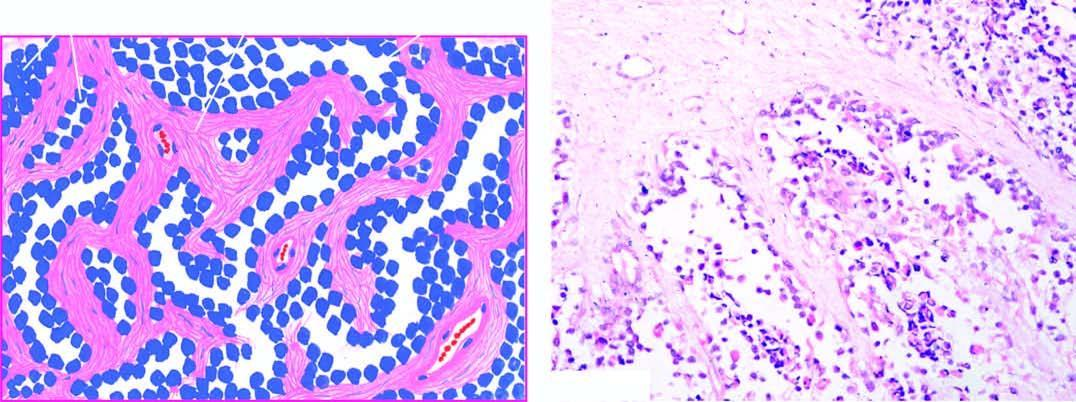re the interface between viable and non-viable area lined by small, dark, undifferentiated tumour cells, with some cells floating in the alveolar spaces?
Answer the question using a single word or phrase. No 